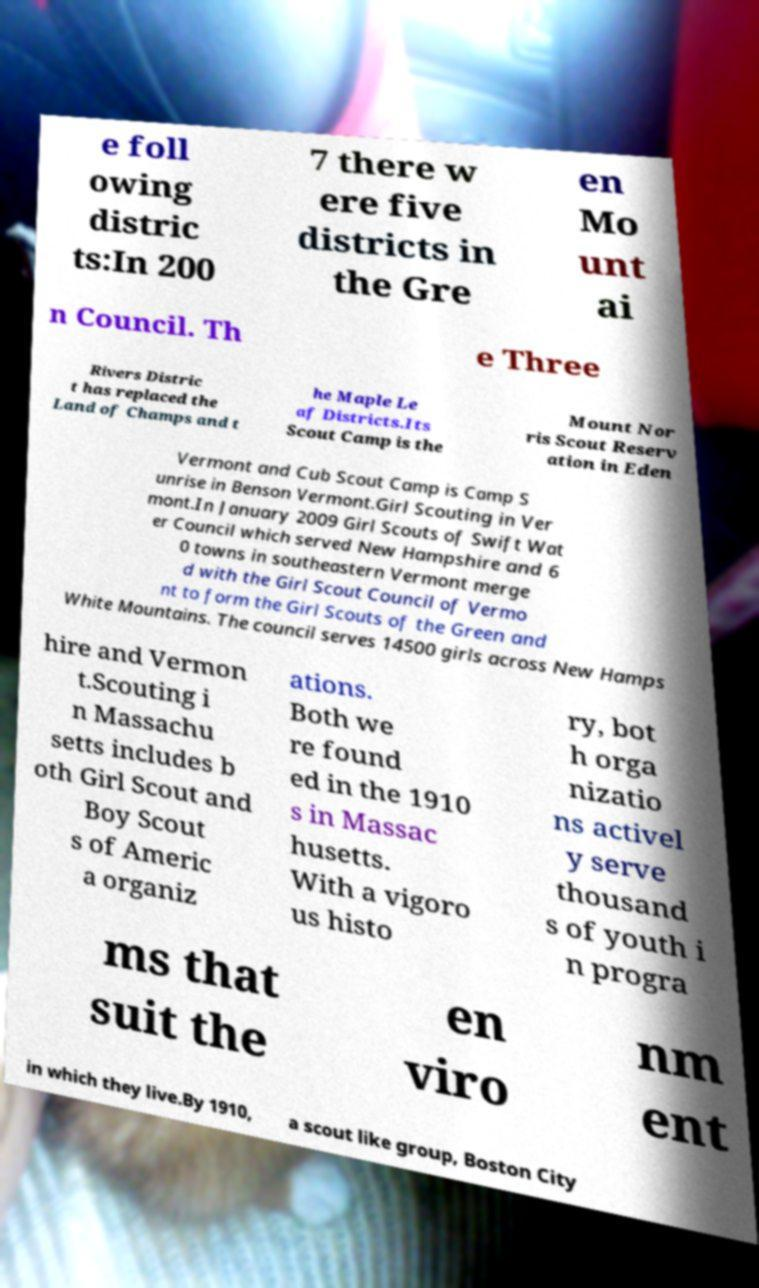Could you extract and type out the text from this image? e foll owing distric ts:In 200 7 there w ere five districts in the Gre en Mo unt ai n Council. Th e Three Rivers Distric t has replaced the Land of Champs and t he Maple Le af Districts.Its Scout Camp is the Mount Nor ris Scout Reserv ation in Eden Vermont and Cub Scout Camp is Camp S unrise in Benson Vermont.Girl Scouting in Ver mont.In January 2009 Girl Scouts of Swift Wat er Council which served New Hampshire and 6 0 towns in southeastern Vermont merge d with the Girl Scout Council of Vermo nt to form the Girl Scouts of the Green and White Mountains. The council serves 14500 girls across New Hamps hire and Vermon t.Scouting i n Massachu setts includes b oth Girl Scout and Boy Scout s of Americ a organiz ations. Both we re found ed in the 1910 s in Massac husetts. With a vigoro us histo ry, bot h orga nizatio ns activel y serve thousand s of youth i n progra ms that suit the en viro nm ent in which they live.By 1910, a scout like group, Boston City 